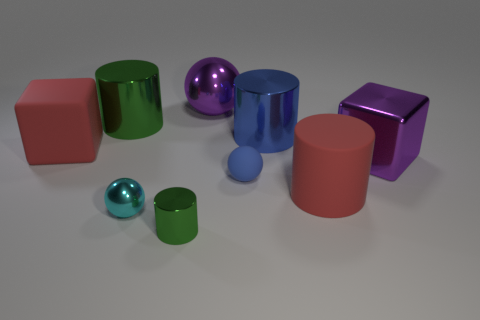Add 1 purple matte balls. How many objects exist? 10 Subtract all cubes. How many objects are left? 7 Subtract 1 cyan balls. How many objects are left? 8 Subtract all red matte objects. Subtract all small matte spheres. How many objects are left? 6 Add 6 large matte cubes. How many large matte cubes are left? 7 Add 4 tiny blue spheres. How many tiny blue spheres exist? 5 